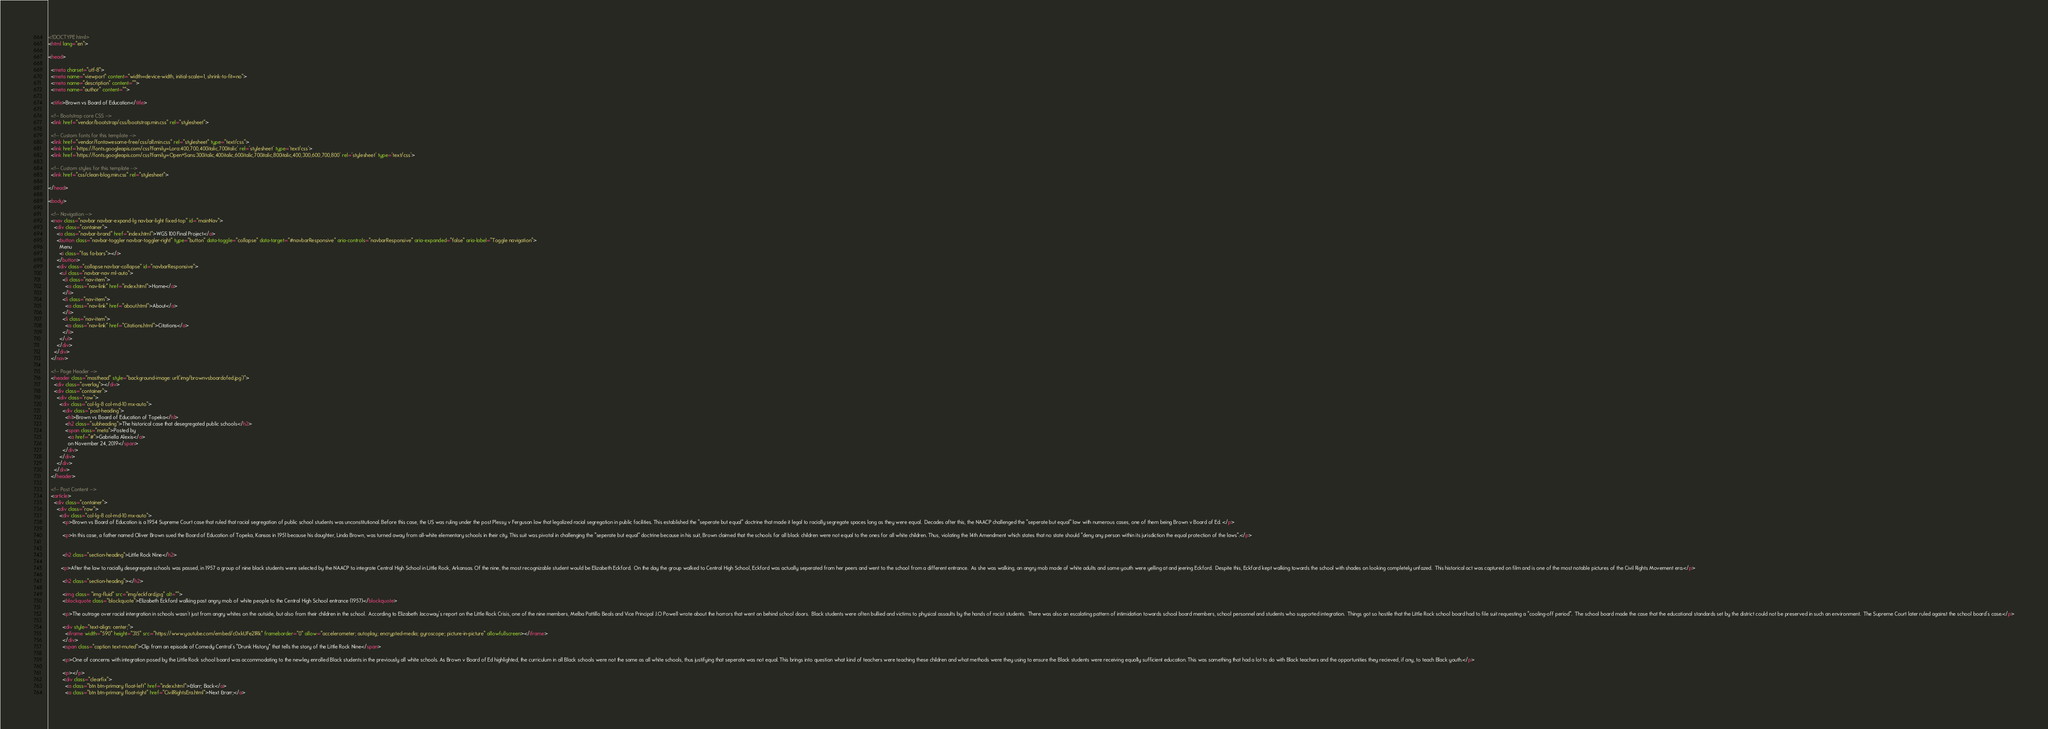Convert code to text. <code><loc_0><loc_0><loc_500><loc_500><_HTML_><!DOCTYPE html>
<html lang="en">

<head>

  <meta charset="utf-8">
  <meta name="viewport" content="width=device-width, initial-scale=1, shrink-to-fit=no">
  <meta name="description" content="">
  <meta name="author" content="">

  <title>Brown vs Board of Education</title>

  <!-- Bootstrap core CSS -->
  <link href="vendor/bootstrap/css/bootstrap.min.css" rel="stylesheet">

  <!-- Custom fonts for this template -->
  <link href="vendor/fontawesome-free/css/all.min.css" rel="stylesheet" type="text/css">
  <link href='https://fonts.googleapis.com/css?family=Lora:400,700,400italic,700italic' rel='stylesheet' type='text/css'>
  <link href='https://fonts.googleapis.com/css?family=Open+Sans:300italic,400italic,600italic,700italic,800italic,400,300,600,700,800' rel='stylesheet' type='text/css'>

  <!-- Custom styles for this template -->
  <link href="css/clean-blog.min.css" rel="stylesheet">

</head>

<body>

  <!-- Navigation -->
  <nav class="navbar navbar-expand-lg navbar-light fixed-top" id="mainNav">
    <div class="container">
      <a class="navbar-brand" href="index.html">WGS 100 Final Project</a>
      <button class="navbar-toggler navbar-toggler-right" type="button" data-toggle="collapse" data-target="#navbarResponsive" aria-controls="navbarResponsive" aria-expanded="false" aria-label="Toggle navigation">
        Menu
        <i class="fas fa-bars"></i>
      </button>
      <div class="collapse navbar-collapse" id="navbarResponsive">
        <ul class="navbar-nav ml-auto">
          <li class="nav-item">
            <a class="nav-link" href="index.html">Home</a>
          </li>
          <li class="nav-item">
            <a class="nav-link" href="about.html">About</a>
          </li>
          <li class="nav-item">
            <a class="nav-link" href="Citations.html">Citations</a>
          </li>
        </ul>
      </div>
    </div>
  </nav>

  <!-- Page Header -->
  <header class="masthead" style="background-image: url('img/brownvsboardofed.jpg')">
    <div class="overlay"></div>
    <div class="container">
      <div class="row">
        <div class="col-lg-8 col-md-10 mx-auto">
          <div class="post-heading">
            <h1>Brown vs Board of Education of Topeka</h1>
            <h2 class="subheading">The historical case that desegregated public schools</h2>
            <span class="meta">Posted by
              <a href="#">Gabriella Alexis</a>
              on November 24, 2019</span>
          </div>
        </div>
      </div>
    </div>
  </header>

  <!-- Post Content -->
  <article>
    <div class="container">
      <div class="row">
        <div class="col-lg-8 col-md-10 mx-auto">
          <p>Brown vs Board of Education is a 1954 Supreme Court case that ruled that racial segregation of public school students was unconstitutional. Before this case, the US was ruling under the post Plessy v Ferguson law that legalized racial segregation in public facilities. This established the "seperate but equal" doctrine that made it legal to racially segregate spaces long as they were equal.  Decades after this, the NAACP challenged the "seperate but equal" law with numerous cases, one of them being Brown v Board of Ed. </p>

          <p>In this case, a father named Oliver Brown sued the Board of Education of Topeka, Kansas in 1951 because his daughter, Linda Brown, was turned away from all-white elementary schools in their city. This suit was pivotal in challenging the "seperate but equal" doctrine because in his suit, Brown claimed that the schools for all black children were not equal to the ones for all white children. Thus, violating the 14th Amendment which states that no state should "deny any person within its jurisdiction the equal protection of the laws".</p>


          <h2 class="section-heading">Little Rock Nine</h2>

         <p>After the law to racially desegregate schools was passed, in 1957 a group of nine black students were selected by the NAACP to integrate Central High School in Little Rock, Arkansas. Of the nine, the most recognizable student would be Elizabeth Eckford.  On the day the group walked to Central High School, Eckford was actually seperated from her peers and went to the school from a different entrance.  As she was walking, an angry mob made of white adults and some youth were yelling at and jeering Eckford.  Despite this, Eckford kept walking towards the school with shades on looking completely unfazed.  This historical act was captured on film and is one of the most notable pictures of the Civil Rights Movement era.</p>

          <h2 class="section-heading"></h2>

          <img class= "img-fluid" src="img/eckford.jpg" alt="">
          <blockquote class="blockquote">Elizabeth Eckford walking past angry mob of white people to the Central High School entrance (1957)</blockquote>

          <p>The outrage over racial intergration in schools wasn't just from angry whites on the outside, but also from their children in the school.  According to Elizabeth Jacoway's report on the Little Rock Crisis, one of the nine members, Melba Pattillo Beals and Vice Principal J.O Powell wrote about the horrors that went on behind school doors.  Black students were often bullied and victims to physical assaults by the hands of racist students.  There was also an escalating pattern of intimidation towards school board members, school personnel and students who supported integration.  Things got so hostile that the Little Rock school board had to file suit requesting a "cooling-off period".  The school board made the case that the educational standards set by the district could not be preserved in such an environment.  The Supreme Court later ruled against the school board's case.</p>
          
          <div style="text-align: center;">
            <iframe width="590" height="315" src="https://www.youtube.com/embed/c0xkUFe21Rk" frameborder="0" allow="accelerometer; autoplay; encrypted-media; gyroscope; picture-in-picture" allowfullscreen></iframe>
          </div>
          <span class="caption text-muted">Clip from an episode of Comedy Central's "Drunk History" that tells the story of the Little Rock Nine</span>

          <p>One of concerns with integration posed by the Little Rock school board was accommodating to the newley enrolled Black students in the previously all white schools. As Brown v Board of Ed highlighted, the curriculum in all Black schools were not the same as all white schools, thus justifying that seperate was not equal. This brings into question what kind of teachers were teaching these children and what methods were they using to ensure the Black students were receiving equally sufficient education. This was something that had a lot to do with Black teachers and the opportunities they recieved, if any, to teach Black youth.</p>

          <p></p>
          <div class="clearfix">
            <a class="btn btn-primary float-left" href="index.html">&larr; Back</a>
            <a class="btn btn-primary float-right" href="CivilRightsEra.html">Next &rarr;</a></code> 